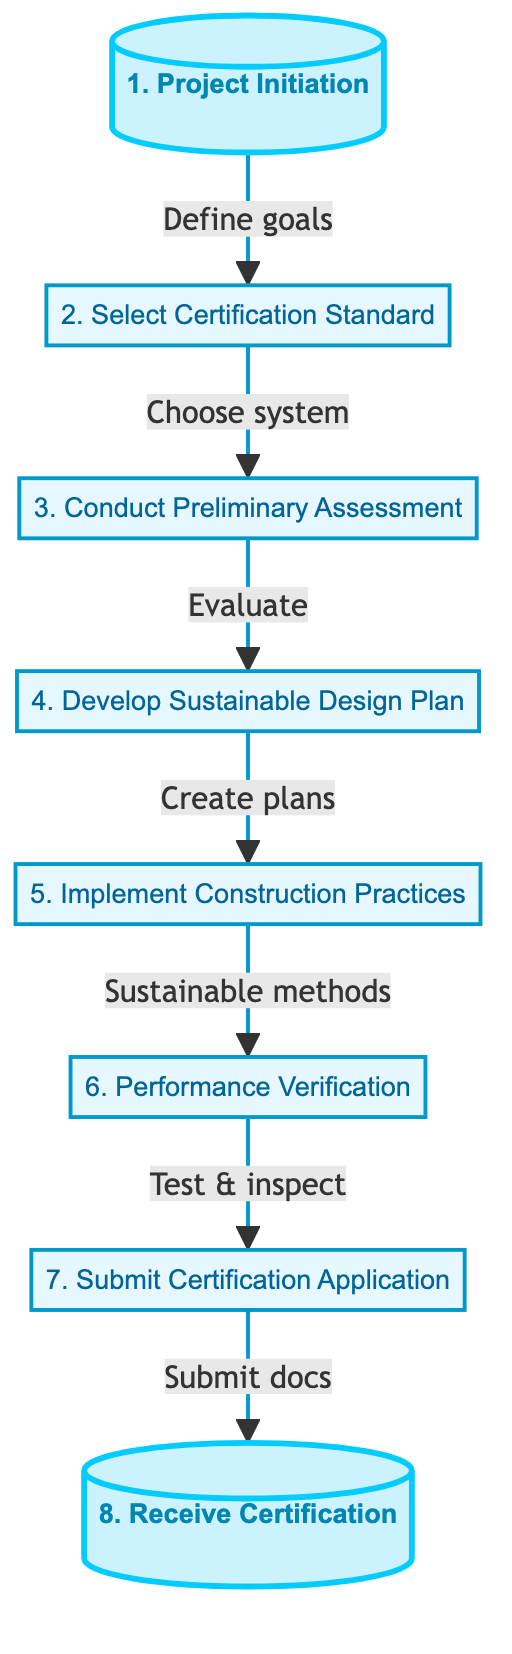What is the first step in the certification process? The diagram identifies "Project Initiation" as the first step, as indicated at the top of the flowchart.
Answer: Project Initiation How many steps are in the green building certification process? By counting the nodes in the diagram, there are a total of eight distinct steps in the flowchart.
Answer: 8 What leads to the "Conduct Preliminary Assessment" step? The diagram shows that the "Select Certification Standard" step directly points to "Conduct Preliminary Assessment," indicating this relationship.
Answer: Select Certification Standard Which step involves creating architectural plans? The step titled "Develop Sustainable Design Plan" specifically mentions creating architectural and engineering plans, highlighting its focus on planning.
Answer: Develop Sustainable Design Plan What is the relationship between "Implement Construction Practices" and "Performance Verification"? The flowchart demonstrates that "Implement Construction Practices" leads to "Performance Verification," indicating that construction practices must be implemented before verification can occur.
Answer: Implement Construction Practices What is required after the "Performance Verification" step? According to the flowchart, after performance verification, the next action is to "Submit Certification Application," making it necessary to submit documents for certification.
Answer: Submit Certification Application Which certification standard is mentioned in the flowchart? The flowchart mentions choosing a green building certification standard, specifically giving examples such as LEED, BREEAM, or Green Globes.
Answer: LEED, BREEAM, or Green Globes What is the last step in the flowchart? The final node in the flowchart is "Receive Certification," indicating this is the end of the process where certification is obtained.
Answer: Receive Certification 